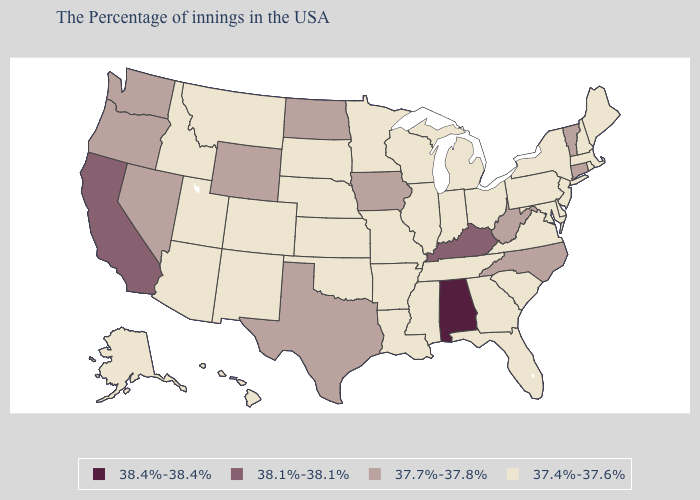What is the value of Nebraska?
Concise answer only. 37.4%-37.6%. What is the highest value in states that border Arizona?
Keep it brief. 38.1%-38.1%. Among the states that border South Dakota , which have the highest value?
Quick response, please. Iowa, North Dakota, Wyoming. What is the value of Michigan?
Keep it brief. 37.4%-37.6%. Name the states that have a value in the range 38.1%-38.1%?
Quick response, please. Kentucky, California. What is the lowest value in the USA?
Short answer required. 37.4%-37.6%. Is the legend a continuous bar?
Keep it brief. No. What is the value of Colorado?
Short answer required. 37.4%-37.6%. What is the lowest value in the West?
Short answer required. 37.4%-37.6%. Does New Hampshire have a lower value than Indiana?
Be succinct. No. Name the states that have a value in the range 37.4%-37.6%?
Answer briefly. Maine, Massachusetts, Rhode Island, New Hampshire, New York, New Jersey, Delaware, Maryland, Pennsylvania, Virginia, South Carolina, Ohio, Florida, Georgia, Michigan, Indiana, Tennessee, Wisconsin, Illinois, Mississippi, Louisiana, Missouri, Arkansas, Minnesota, Kansas, Nebraska, Oklahoma, South Dakota, Colorado, New Mexico, Utah, Montana, Arizona, Idaho, Alaska, Hawaii. Does New Mexico have the lowest value in the USA?
Concise answer only. Yes. Name the states that have a value in the range 38.4%-38.4%?
Give a very brief answer. Alabama. Does Arizona have the lowest value in the USA?
Concise answer only. Yes. How many symbols are there in the legend?
Give a very brief answer. 4. 